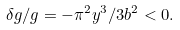Convert formula to latex. <formula><loc_0><loc_0><loc_500><loc_500>\delta g / g = - \pi ^ { 2 } y ^ { 3 } / 3 b ^ { 2 } < 0 .</formula> 